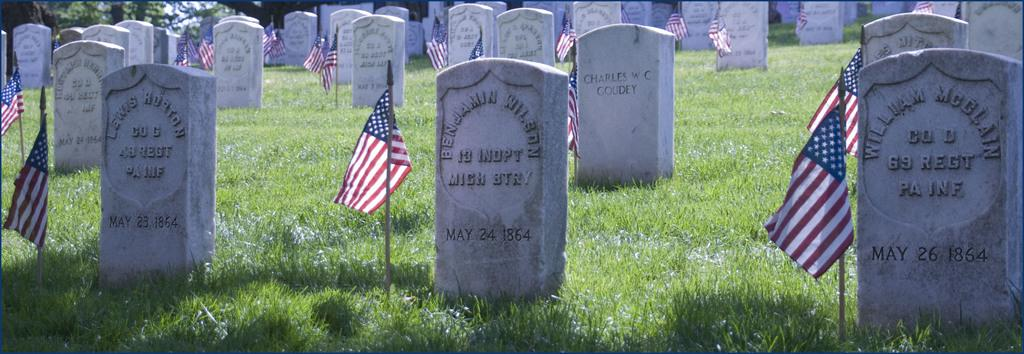What type of location is depicted in the image? The image contains graveyards. What objects can be seen in the image besides the graveyards? There are flags and grass visible in the image. What can be seen in the background of the image? There are trees in the background of the image. How many goldfish can be seen swimming in the grass in the image? There are no goldfish present in the image; it features graveyards, flags, grass, and trees. What type of finger can be seen touching the flags in the image? There are no fingers visible in the image; it only shows graveyards, flags, grass, and trees. 